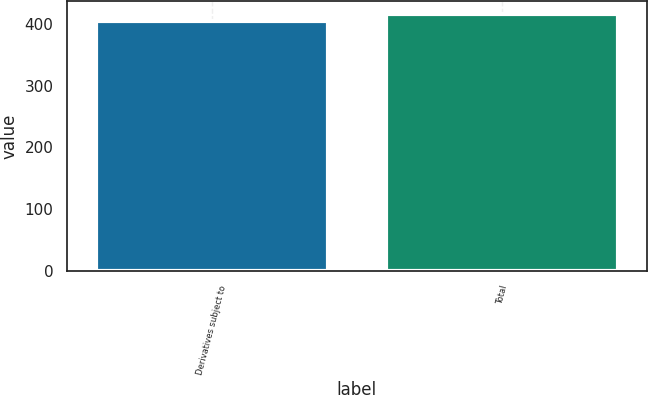Convert chart to OTSL. <chart><loc_0><loc_0><loc_500><loc_500><bar_chart><fcel>Derivatives subject to<fcel>Total<nl><fcel>405<fcel>416<nl></chart> 